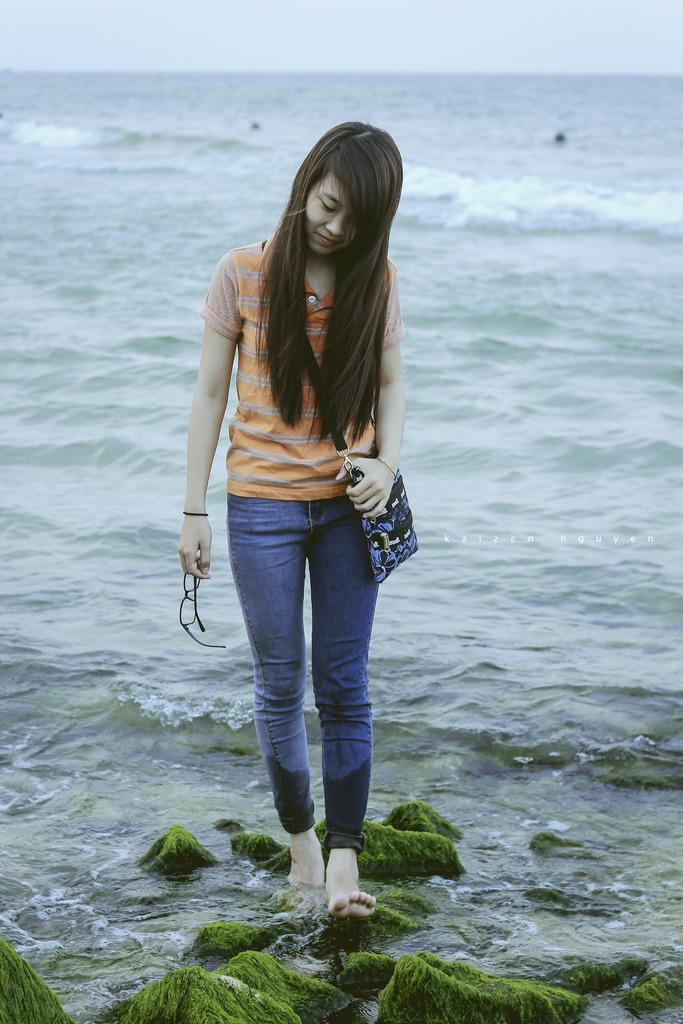Who is the main subject in the picture? There is a young woman in the picture. What is the woman doing in the image? The woman is standing on rocks in the water. What accessories is the woman wearing in the image? The woman is wearing a handbag and glasses. What can be seen in the background of the image? There is water and the sky visible in the background of the image. What type of vegetable is the woman holding in the image? There is no vegetable present in the image; the woman is standing on rocks in the water and wearing a handbag and glasses. 